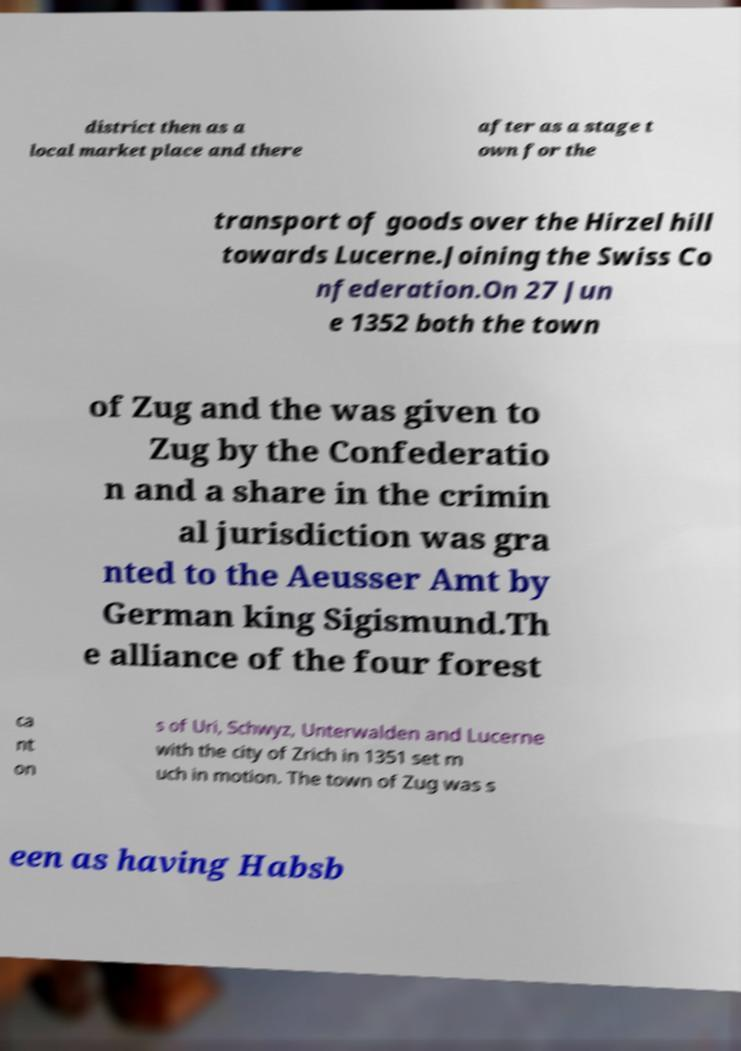There's text embedded in this image that I need extracted. Can you transcribe it verbatim? district then as a local market place and there after as a stage t own for the transport of goods over the Hirzel hill towards Lucerne.Joining the Swiss Co nfederation.On 27 Jun e 1352 both the town of Zug and the was given to Zug by the Confederatio n and a share in the crimin al jurisdiction was gra nted to the Aeusser Amt by German king Sigismund.Th e alliance of the four forest ca nt on s of Uri, Schwyz, Unterwalden and Lucerne with the city of Zrich in 1351 set m uch in motion. The town of Zug was s een as having Habsb 